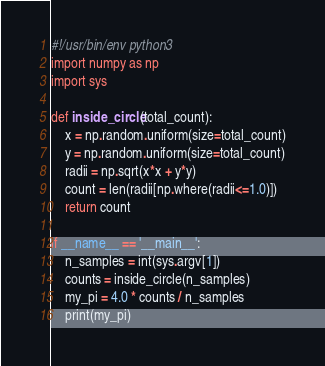Convert code to text. <code><loc_0><loc_0><loc_500><loc_500><_Python_>#!/usr/bin/env python3
import numpy as np
import sys

def inside_circle(total_count):
    x = np.random.uniform(size=total_count)
    y = np.random.uniform(size=total_count)
    radii = np.sqrt(x*x + y*y)
    count = len(radii[np.where(radii<=1.0)])
    return count

if __name__ == '__main__':
    n_samples = int(sys.argv[1])
    counts = inside_circle(n_samples)
    my_pi = 4.0 * counts / n_samples
    print(my_pi)
</code> 